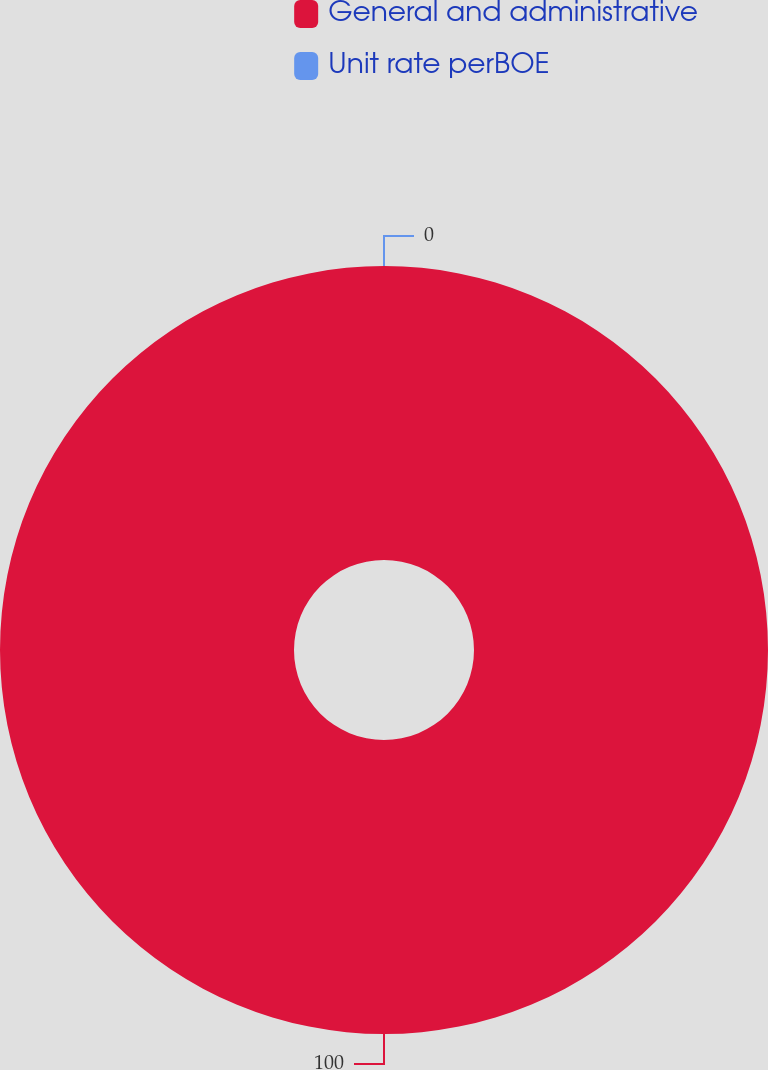Convert chart to OTSL. <chart><loc_0><loc_0><loc_500><loc_500><pie_chart><fcel>General and administrative<fcel>Unit rate perBOE<nl><fcel>100.0%<fcel>0.0%<nl></chart> 